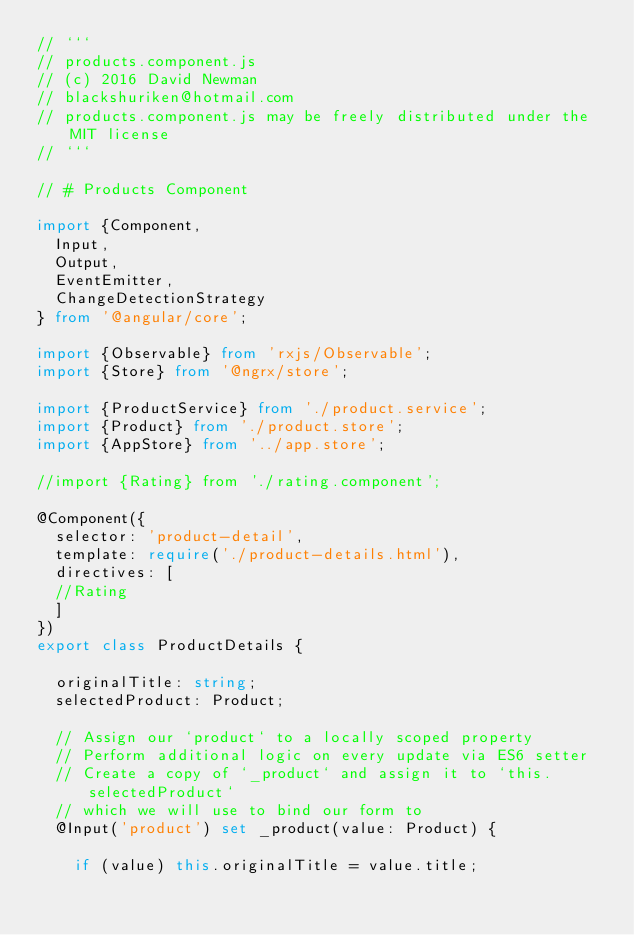<code> <loc_0><loc_0><loc_500><loc_500><_TypeScript_>// ```
// products.component.js
// (c) 2016 David Newman
// blackshuriken@hotmail.com
// products.component.js may be freely distributed under the MIT license
// ```

// # Products Component

import {Component,
  Input,
  Output,
  EventEmitter,
  ChangeDetectionStrategy
} from '@angular/core';

import {Observable} from 'rxjs/Observable';
import {Store} from '@ngrx/store';

import {ProductService} from './product.service';
import {Product} from './product.store';
import {AppStore} from '../app.store';

//import {Rating} from './rating.component';

@Component({
  selector: 'product-detail',
  template: require('./product-details.html'),
  directives: [
	//Rating
  ]
})
export class ProductDetails {

  originalTitle: string;
  selectedProduct: Product;

  // Assign our `product` to a locally scoped property
  // Perform additional logic on every update via ES6 setter
  // Create a copy of `_product` and assign it to `this.selectedProduct`
  // which we will use to bind our form to
  @Input('product') set _product(value: Product) {

    if (value) this.originalTitle = value.title;</code> 